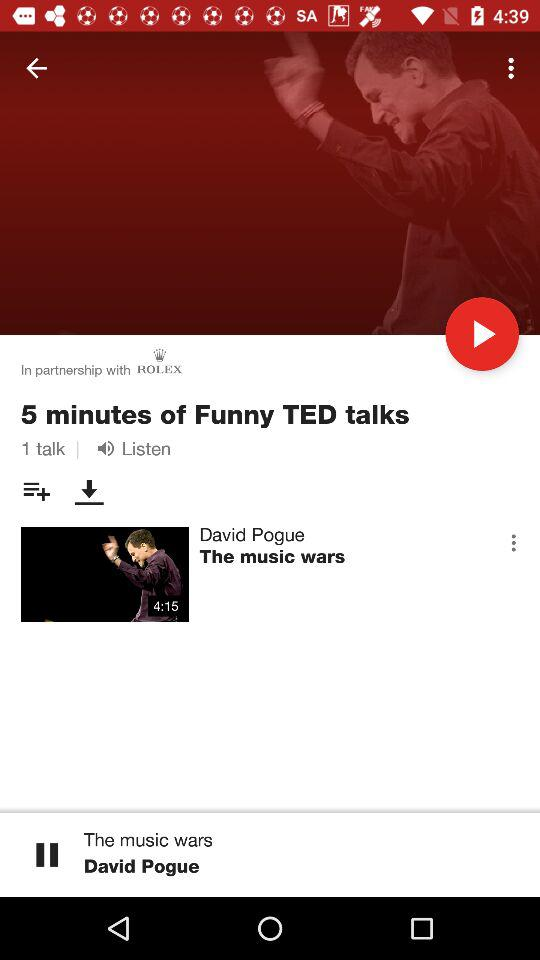What's the time duration for the video "The music wars"? The time duration is 4:15. 